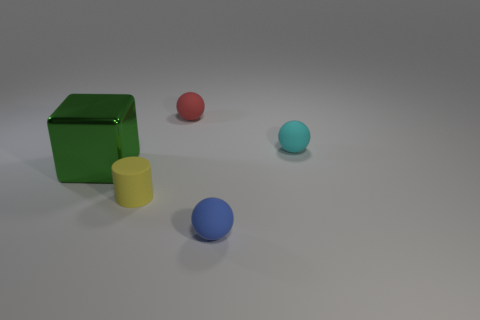Subtract all red spheres. How many spheres are left? 2 Add 3 small cyan metal things. How many objects exist? 8 Subtract all cubes. How many objects are left? 4 Subtract all blue spheres. How many spheres are left? 2 Subtract 1 cylinders. How many cylinders are left? 0 Add 4 yellow cylinders. How many yellow cylinders are left? 5 Add 5 cyan matte cylinders. How many cyan matte cylinders exist? 5 Subtract 0 yellow spheres. How many objects are left? 5 Subtract all green spheres. Subtract all purple cubes. How many spheres are left? 3 Subtract all tiny cylinders. Subtract all tiny cyan spheres. How many objects are left? 3 